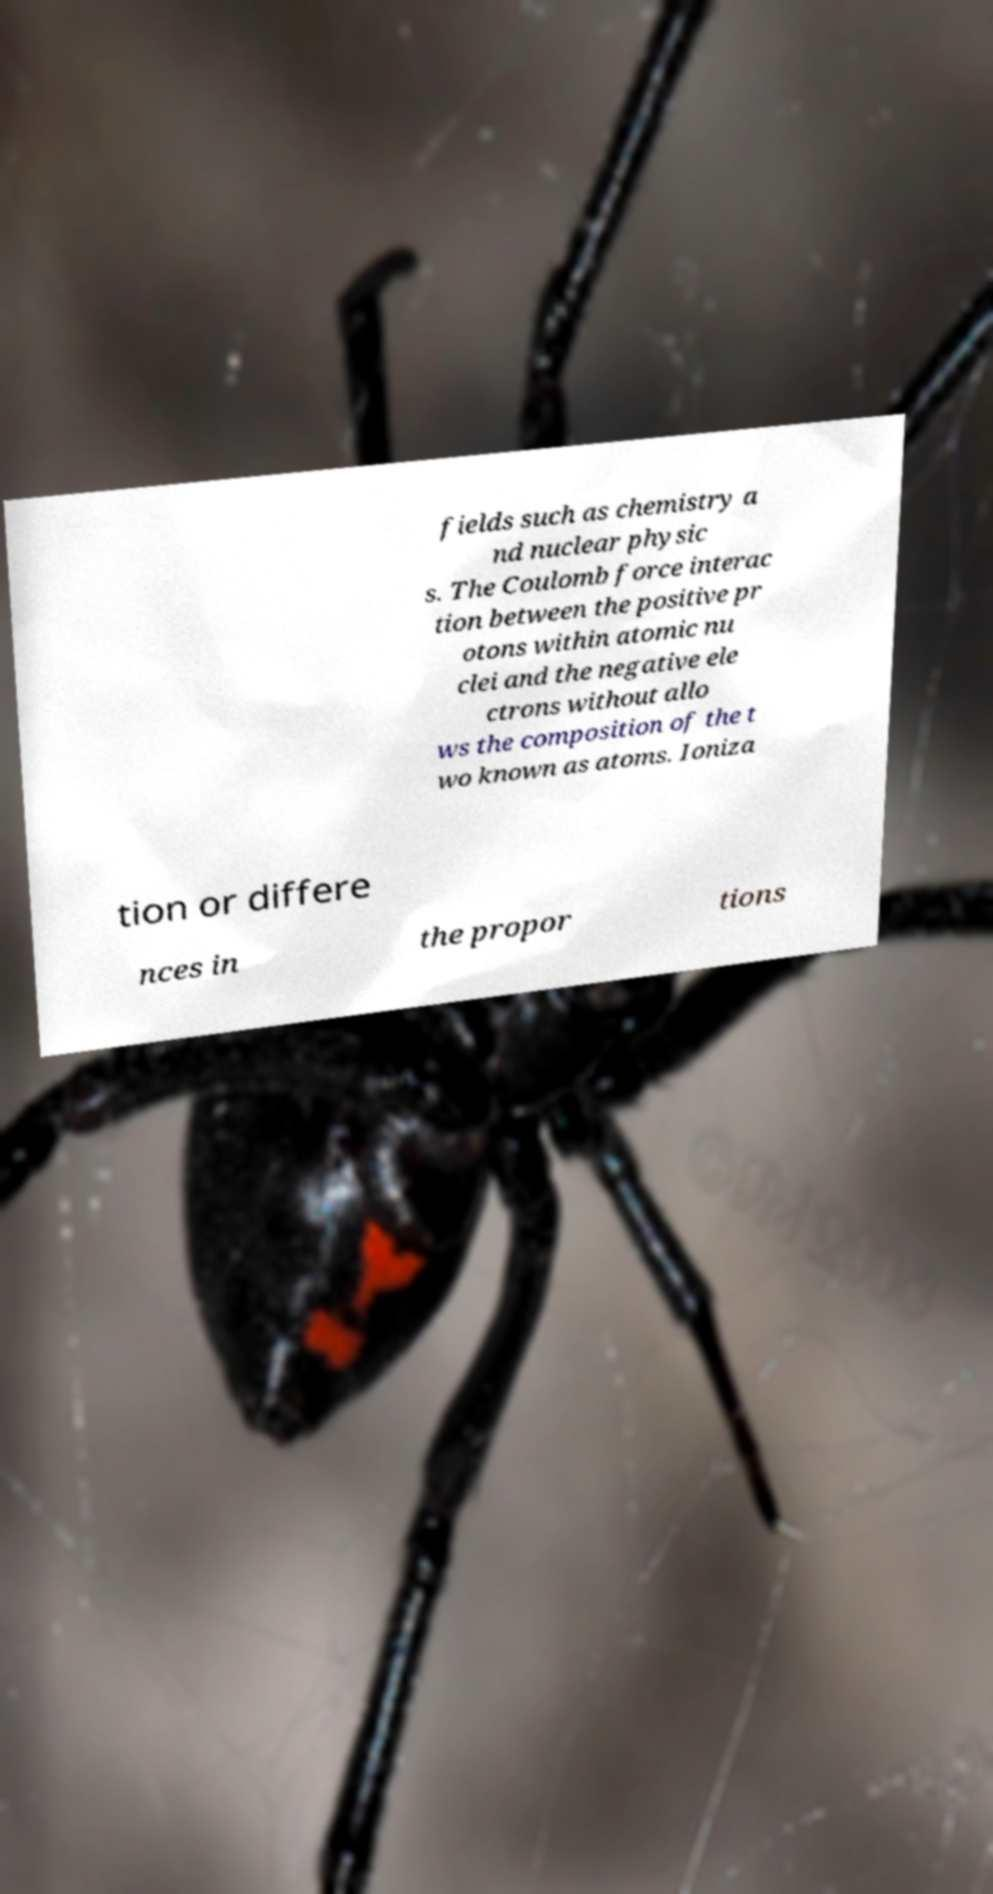Can you accurately transcribe the text from the provided image for me? fields such as chemistry a nd nuclear physic s. The Coulomb force interac tion between the positive pr otons within atomic nu clei and the negative ele ctrons without allo ws the composition of the t wo known as atoms. Ioniza tion or differe nces in the propor tions 